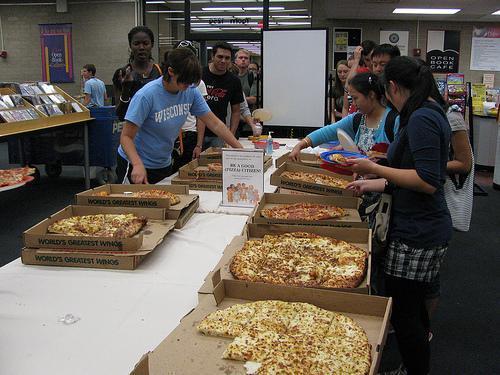How many pizzas are there?
Give a very brief answer. 9. 